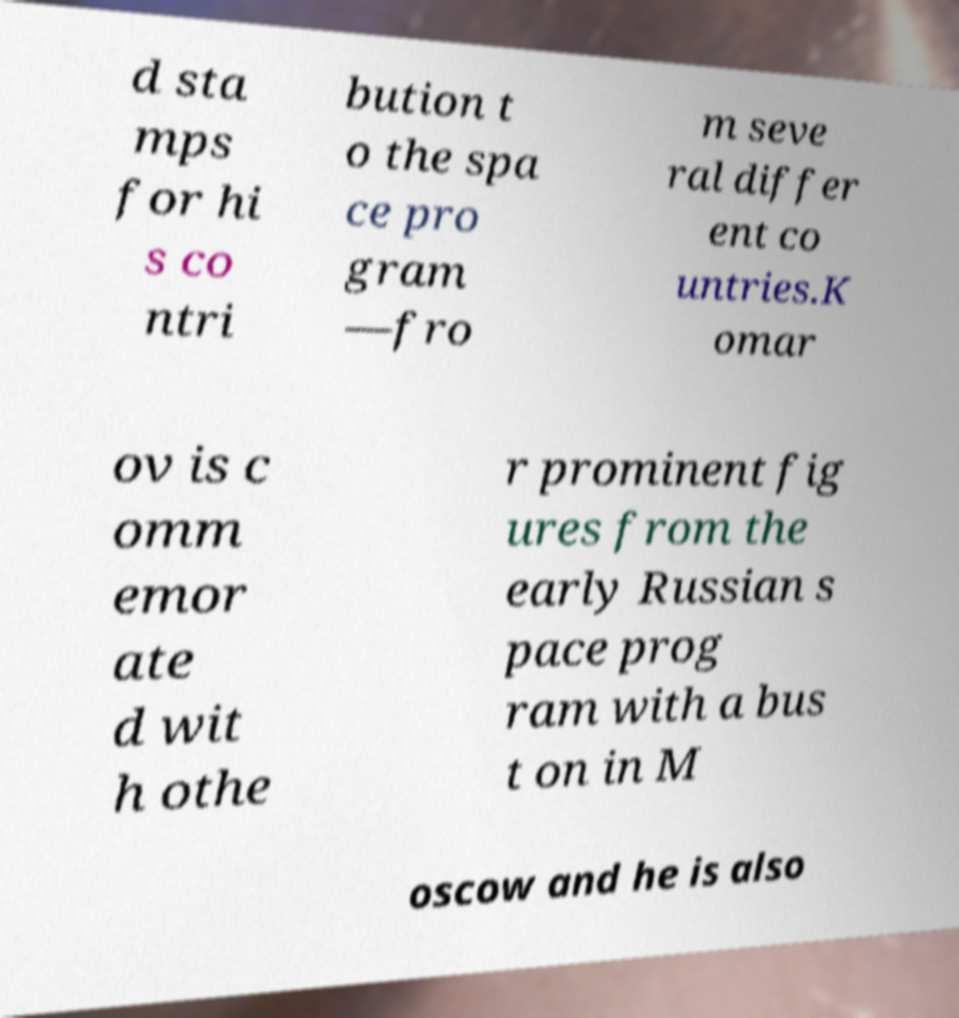What messages or text are displayed in this image? I need them in a readable, typed format. d sta mps for hi s co ntri bution t o the spa ce pro gram —fro m seve ral differ ent co untries.K omar ov is c omm emor ate d wit h othe r prominent fig ures from the early Russian s pace prog ram with a bus t on in M oscow and he is also 